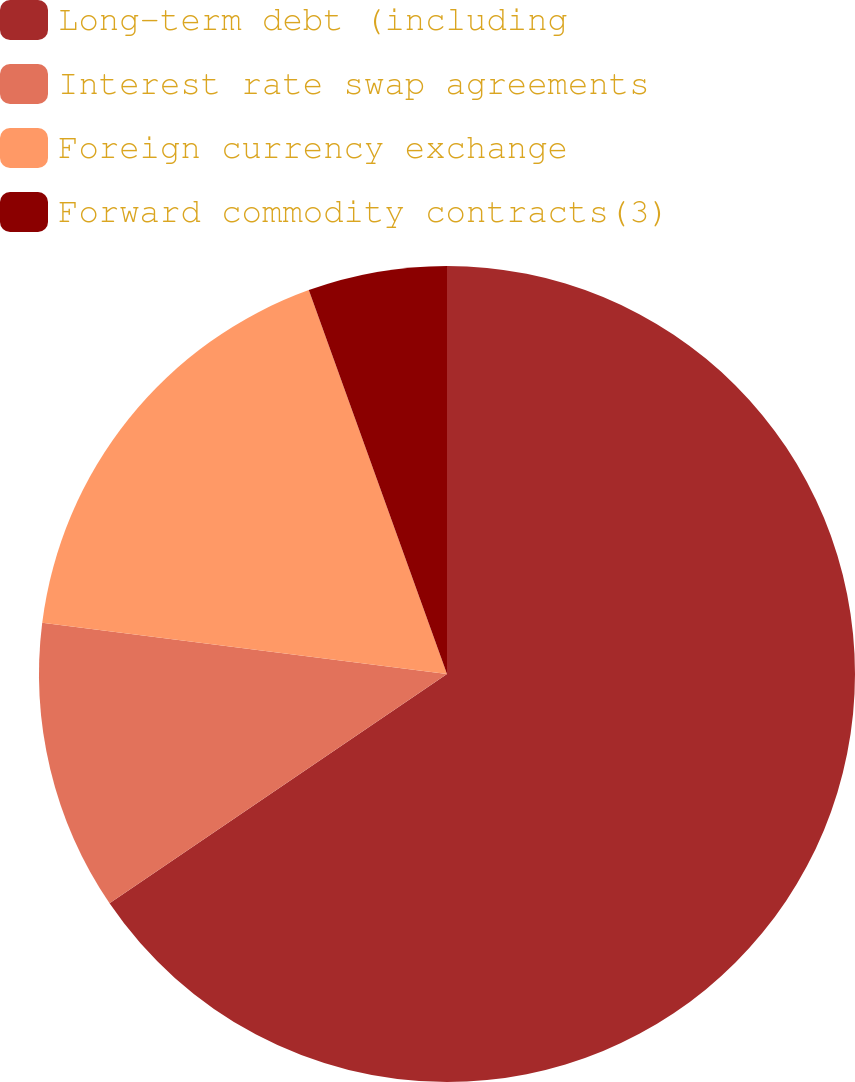<chart> <loc_0><loc_0><loc_500><loc_500><pie_chart><fcel>Long-term debt (including<fcel>Interest rate swap agreements<fcel>Foreign currency exchange<fcel>Forward commodity contracts(3)<nl><fcel>65.5%<fcel>11.5%<fcel>17.5%<fcel>5.5%<nl></chart> 